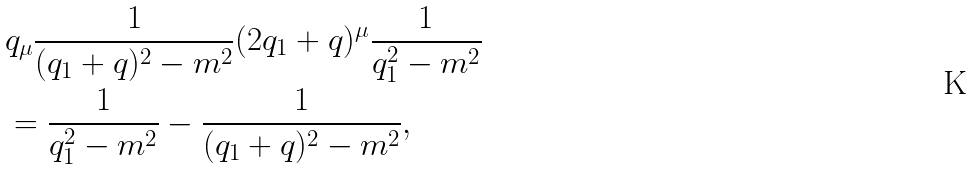Convert formula to latex. <formula><loc_0><loc_0><loc_500><loc_500>& q _ { \mu } \frac { 1 } { ( q _ { 1 } + q ) ^ { 2 } - m ^ { 2 } } ( 2 q _ { 1 } + q ) ^ { \mu } \frac { 1 } { q _ { 1 } ^ { 2 } - m ^ { 2 } } \\ & = \frac { 1 } { q _ { 1 } ^ { 2 } - m ^ { 2 } } - \frac { 1 } { ( q _ { 1 } + q ) ^ { 2 } - m ^ { 2 } } ,</formula> 